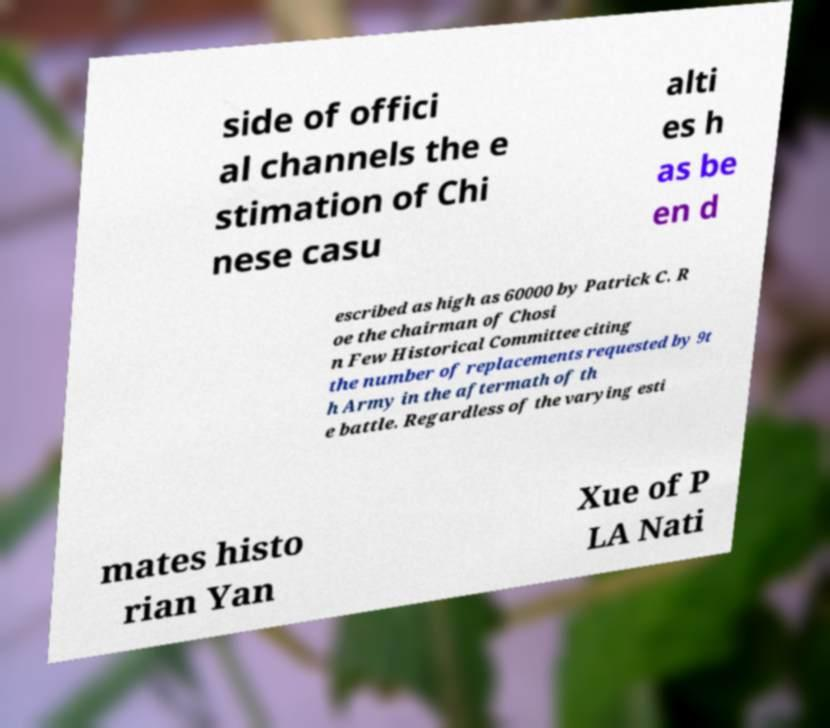Can you read and provide the text displayed in the image?This photo seems to have some interesting text. Can you extract and type it out for me? side of offici al channels the e stimation of Chi nese casu alti es h as be en d escribed as high as 60000 by Patrick C. R oe the chairman of Chosi n Few Historical Committee citing the number of replacements requested by 9t h Army in the aftermath of th e battle. Regardless of the varying esti mates histo rian Yan Xue of P LA Nati 